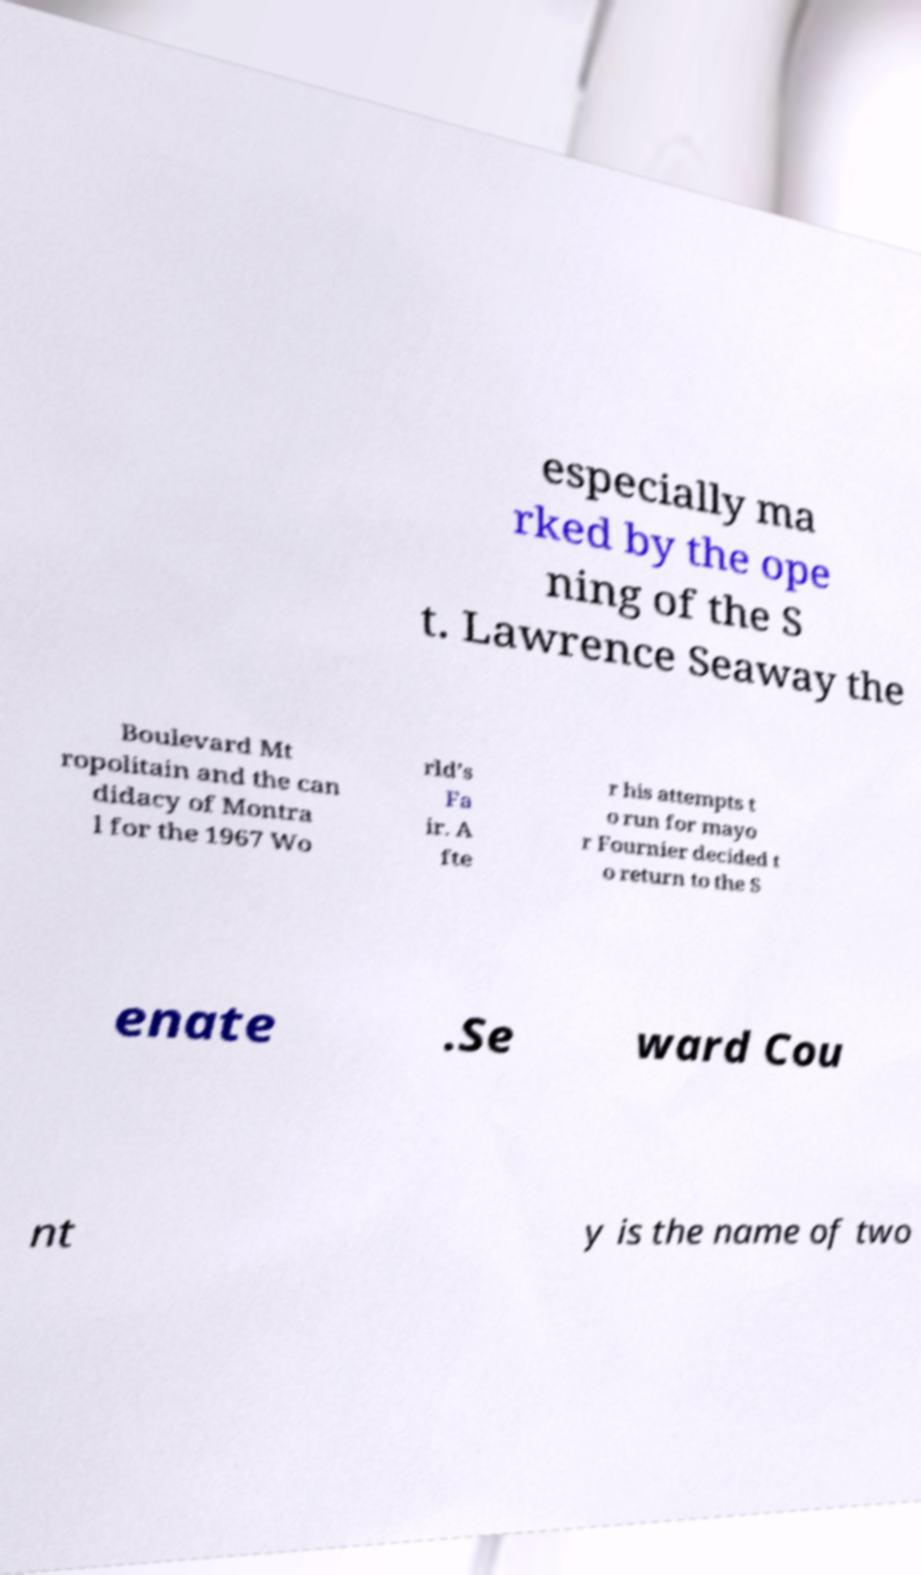Could you assist in decoding the text presented in this image and type it out clearly? especially ma rked by the ope ning of the S t. Lawrence Seaway the Boulevard Mt ropolitain and the can didacy of Montra l for the 1967 Wo rld’s Fa ir. A fte r his attempts t o run for mayo r Fournier decided t o return to the S enate .Se ward Cou nt y is the name of two 